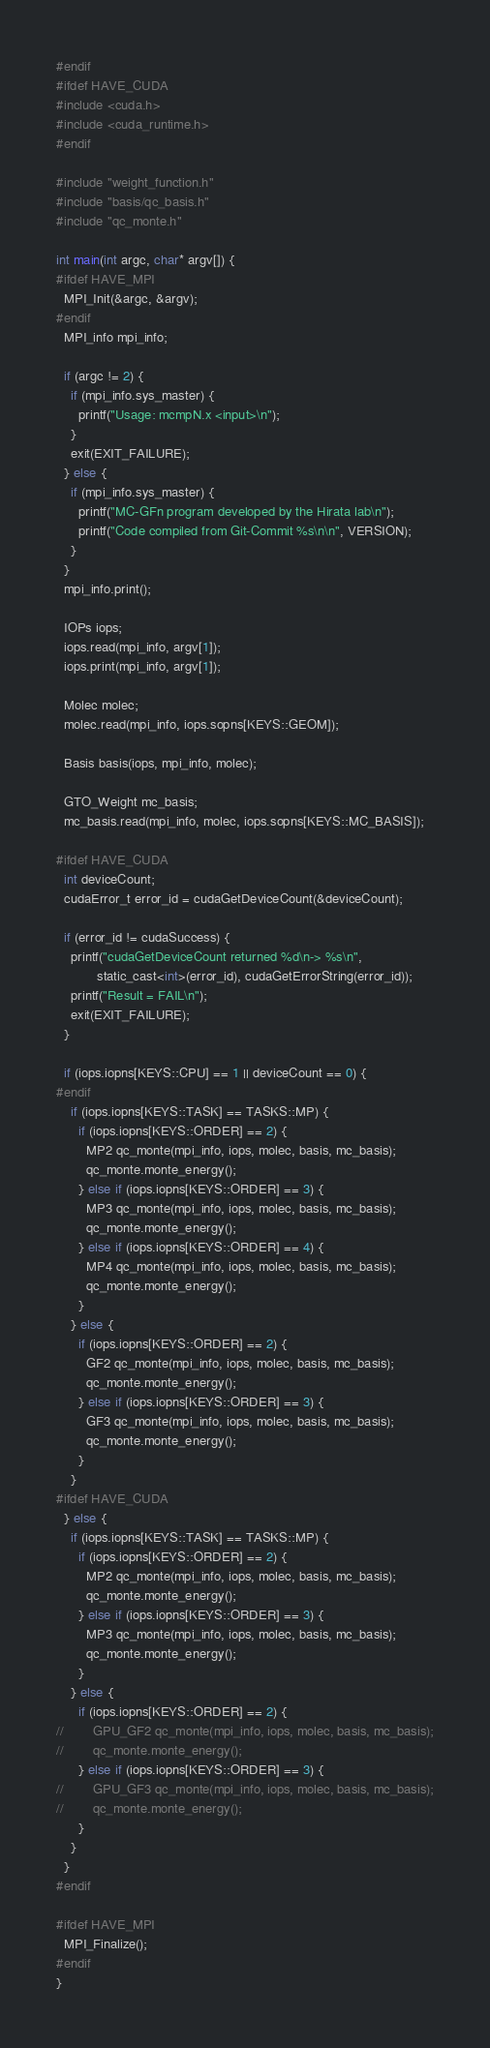<code> <loc_0><loc_0><loc_500><loc_500><_Cuda_>#endif
#ifdef HAVE_CUDA
#include <cuda.h>
#include <cuda_runtime.h>
#endif

#include "weight_function.h"
#include "basis/qc_basis.h"
#include "qc_monte.h"

int main(int argc, char* argv[]) {
#ifdef HAVE_MPI
  MPI_Init(&argc, &argv);
#endif
  MPI_info mpi_info;

  if (argc != 2) {
    if (mpi_info.sys_master) {
      printf("Usage: mcmpN.x <input>\n");
    }
    exit(EXIT_FAILURE);
  } else {
    if (mpi_info.sys_master) {
      printf("MC-GFn program developed by the Hirata lab\n");
      printf("Code compiled from Git-Commit %s\n\n", VERSION);
    }
  }
  mpi_info.print();

  IOPs iops;
  iops.read(mpi_info, argv[1]);
  iops.print(mpi_info, argv[1]);

  Molec molec;
  molec.read(mpi_info, iops.sopns[KEYS::GEOM]);

  Basis basis(iops, mpi_info, molec);

  GTO_Weight mc_basis;
  mc_basis.read(mpi_info, molec, iops.sopns[KEYS::MC_BASIS]);

#ifdef HAVE_CUDA
  int deviceCount;
  cudaError_t error_id = cudaGetDeviceCount(&deviceCount);

  if (error_id != cudaSuccess) {
    printf("cudaGetDeviceCount returned %d\n-> %s\n",
           static_cast<int>(error_id), cudaGetErrorString(error_id));
    printf("Result = FAIL\n");
    exit(EXIT_FAILURE);
  }

  if (iops.iopns[KEYS::CPU] == 1 || deviceCount == 0) {
#endif
    if (iops.iopns[KEYS::TASK] == TASKS::MP) {
      if (iops.iopns[KEYS::ORDER] == 2) {
        MP2 qc_monte(mpi_info, iops, molec, basis, mc_basis);
        qc_monte.monte_energy();
      } else if (iops.iopns[KEYS::ORDER] == 3) {
        MP3 qc_monte(mpi_info, iops, molec, basis, mc_basis);
        qc_monte.monte_energy();
      } else if (iops.iopns[KEYS::ORDER] == 4) {
        MP4 qc_monte(mpi_info, iops, molec, basis, mc_basis);
        qc_monte.monte_energy();
      }
    } else {
      if (iops.iopns[KEYS::ORDER] == 2) {
        GF2 qc_monte(mpi_info, iops, molec, basis, mc_basis);
        qc_monte.monte_energy();
      } else if (iops.iopns[KEYS::ORDER] == 3) {
        GF3 qc_monte(mpi_info, iops, molec, basis, mc_basis);
        qc_monte.monte_energy();
      }
    }
#ifdef HAVE_CUDA
  } else {
    if (iops.iopns[KEYS::TASK] == TASKS::MP) {
      if (iops.iopns[KEYS::ORDER] == 2) {
        MP2 qc_monte(mpi_info, iops, molec, basis, mc_basis);
        qc_monte.monte_energy();
      } else if (iops.iopns[KEYS::ORDER] == 3) {
        MP3 qc_monte(mpi_info, iops, molec, basis, mc_basis);
        qc_monte.monte_energy();
      }
    } else {
      if (iops.iopns[KEYS::ORDER] == 2) {
//        GPU_GF2 qc_monte(mpi_info, iops, molec, basis, mc_basis);
//        qc_monte.monte_energy();
      } else if (iops.iopns[KEYS::ORDER] == 3) {
//        GPU_GF3 qc_monte(mpi_info, iops, molec, basis, mc_basis);
//        qc_monte.monte_energy();
      }
    }
  }
#endif

#ifdef HAVE_MPI
  MPI_Finalize();
#endif
}
</code> 